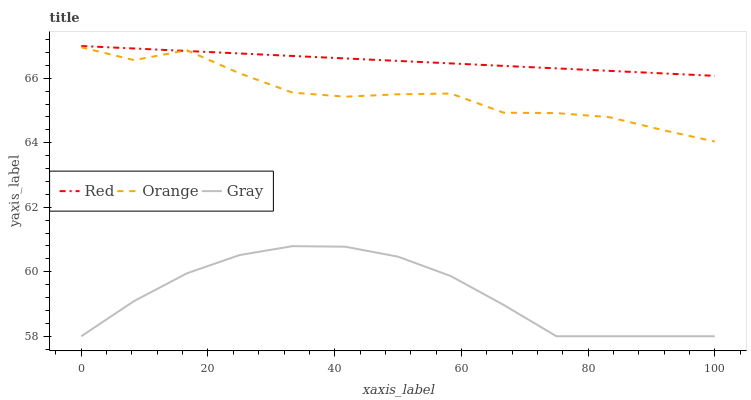Does Gray have the minimum area under the curve?
Answer yes or no. Yes. Does Red have the maximum area under the curve?
Answer yes or no. Yes. Does Red have the minimum area under the curve?
Answer yes or no. No. Does Gray have the maximum area under the curve?
Answer yes or no. No. Is Red the smoothest?
Answer yes or no. Yes. Is Orange the roughest?
Answer yes or no. Yes. Is Gray the smoothest?
Answer yes or no. No. Is Gray the roughest?
Answer yes or no. No. Does Red have the lowest value?
Answer yes or no. No. Does Red have the highest value?
Answer yes or no. Yes. Does Gray have the highest value?
Answer yes or no. No. Is Gray less than Red?
Answer yes or no. Yes. Is Red greater than Gray?
Answer yes or no. Yes. Does Orange intersect Red?
Answer yes or no. Yes. Is Orange less than Red?
Answer yes or no. No. Is Orange greater than Red?
Answer yes or no. No. Does Gray intersect Red?
Answer yes or no. No. 